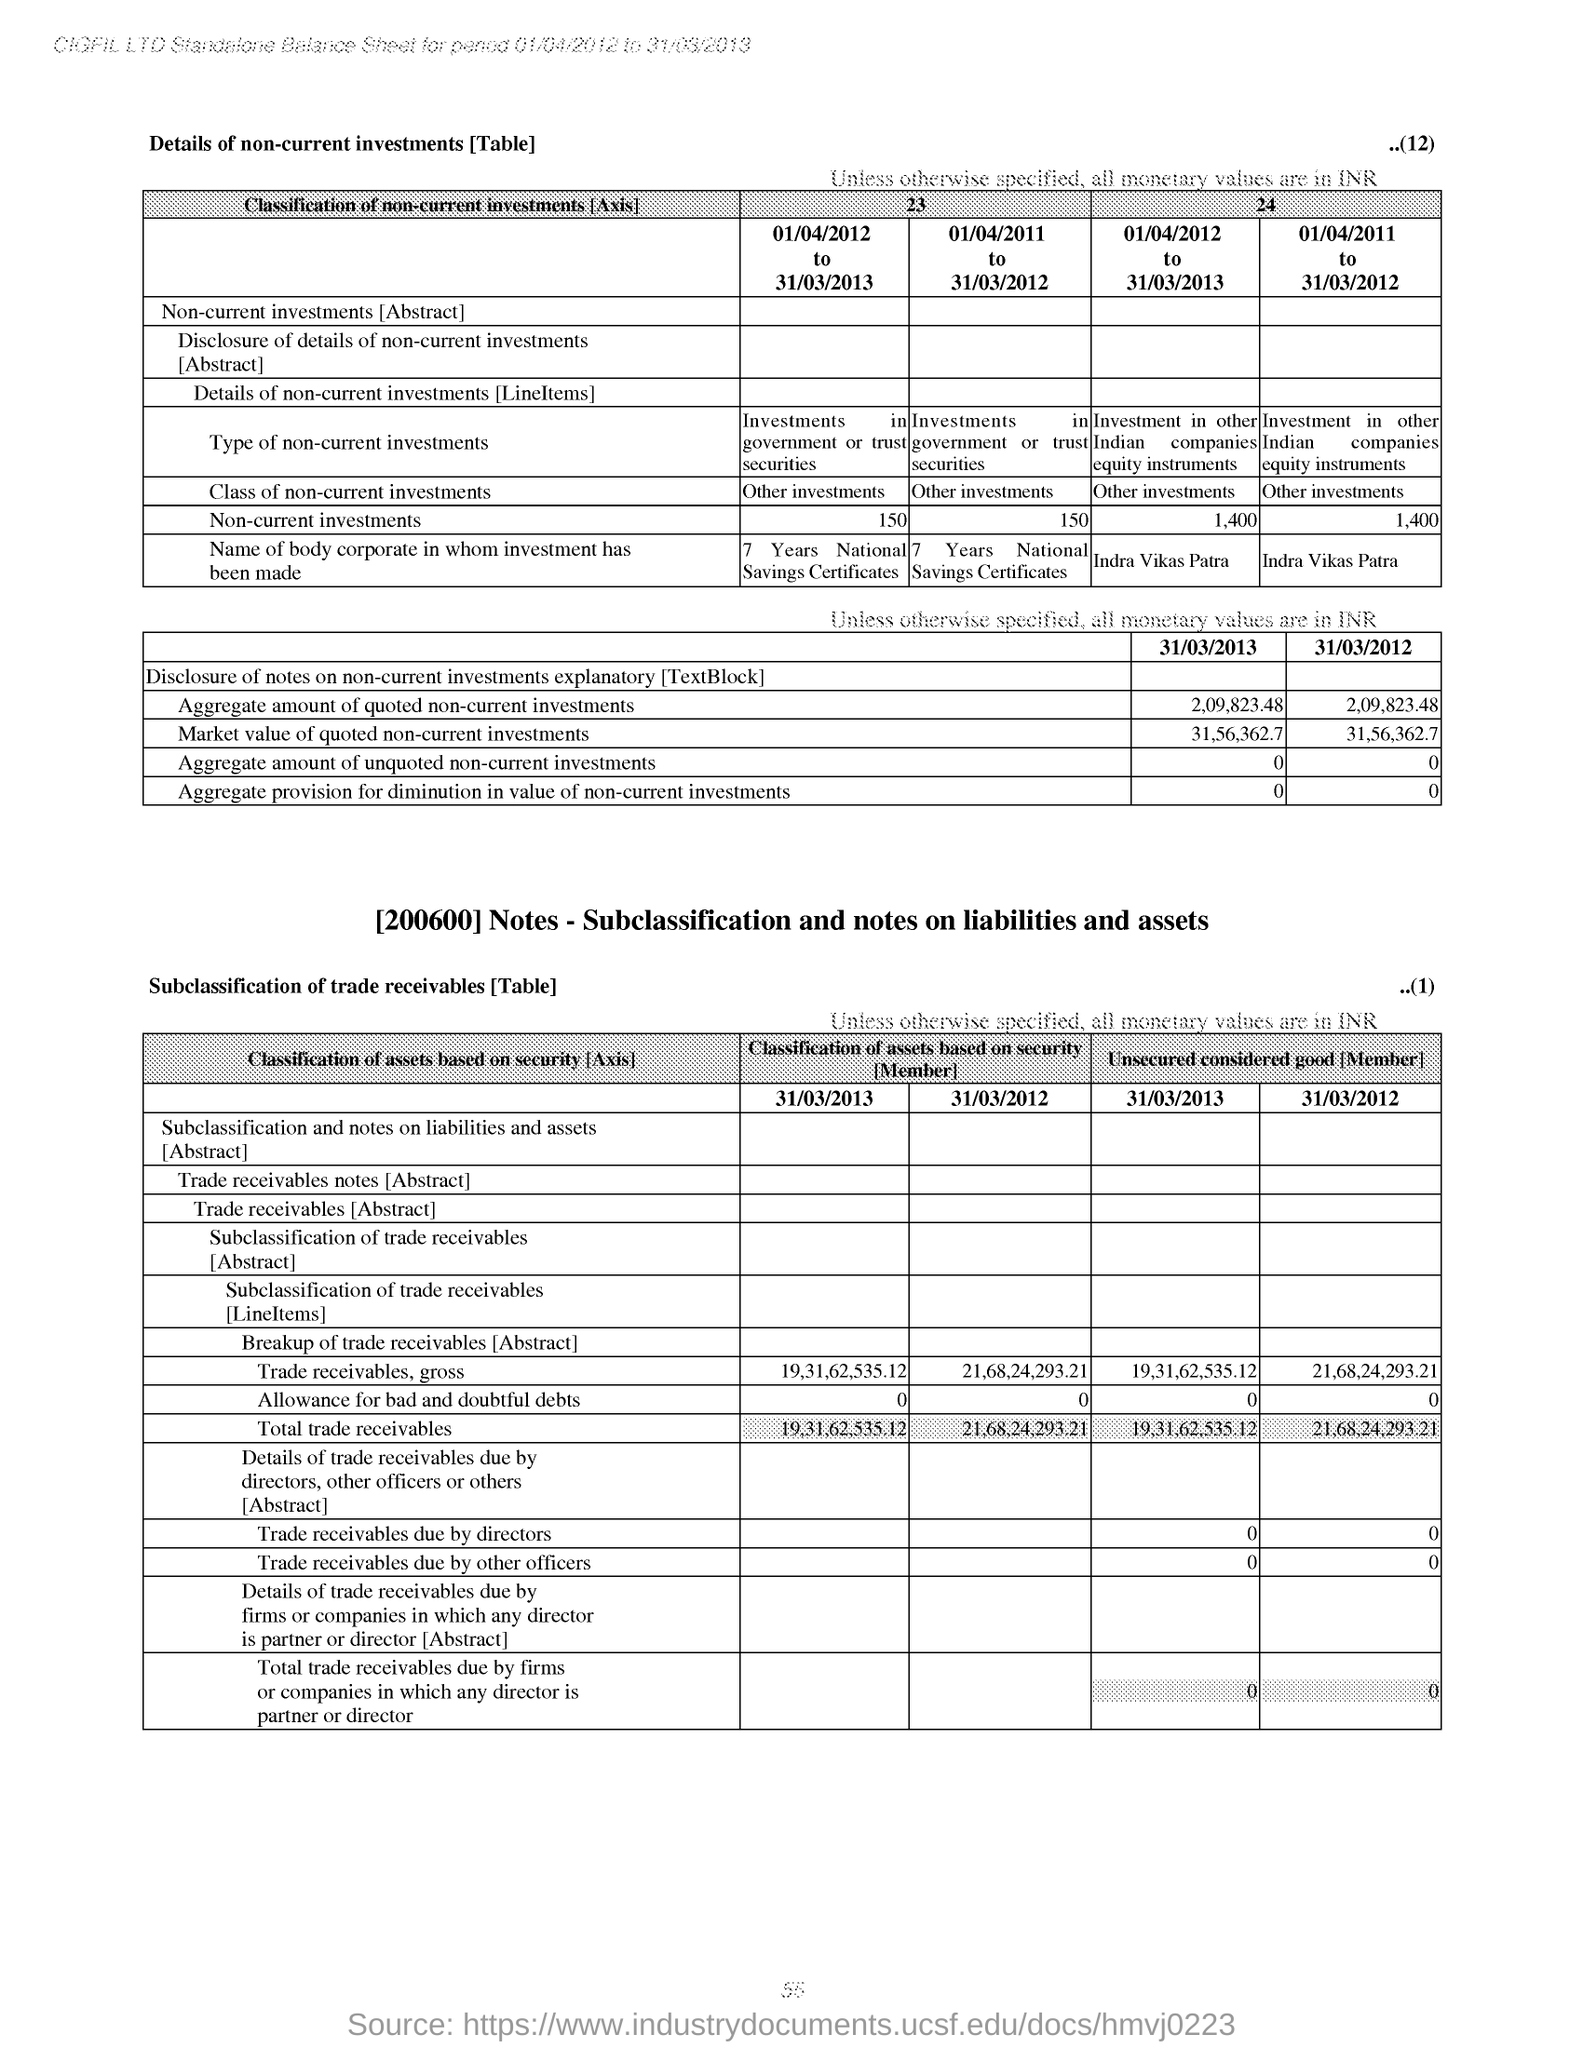Draw attention to some important aspects in this diagram. The market value of quoted non-current investments for the date of March 31, 2013, as per the second table, is 31,56,362.70. Non-current investments for the period 01/04/2011 to 31/03/2012 in the first table are 1,400. 